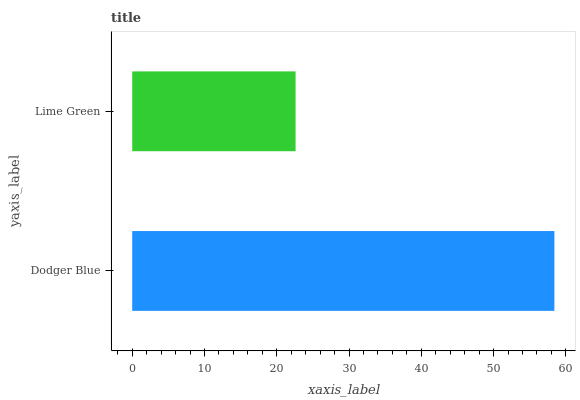Is Lime Green the minimum?
Answer yes or no. Yes. Is Dodger Blue the maximum?
Answer yes or no. Yes. Is Lime Green the maximum?
Answer yes or no. No. Is Dodger Blue greater than Lime Green?
Answer yes or no. Yes. Is Lime Green less than Dodger Blue?
Answer yes or no. Yes. Is Lime Green greater than Dodger Blue?
Answer yes or no. No. Is Dodger Blue less than Lime Green?
Answer yes or no. No. Is Dodger Blue the high median?
Answer yes or no. Yes. Is Lime Green the low median?
Answer yes or no. Yes. Is Lime Green the high median?
Answer yes or no. No. Is Dodger Blue the low median?
Answer yes or no. No. 